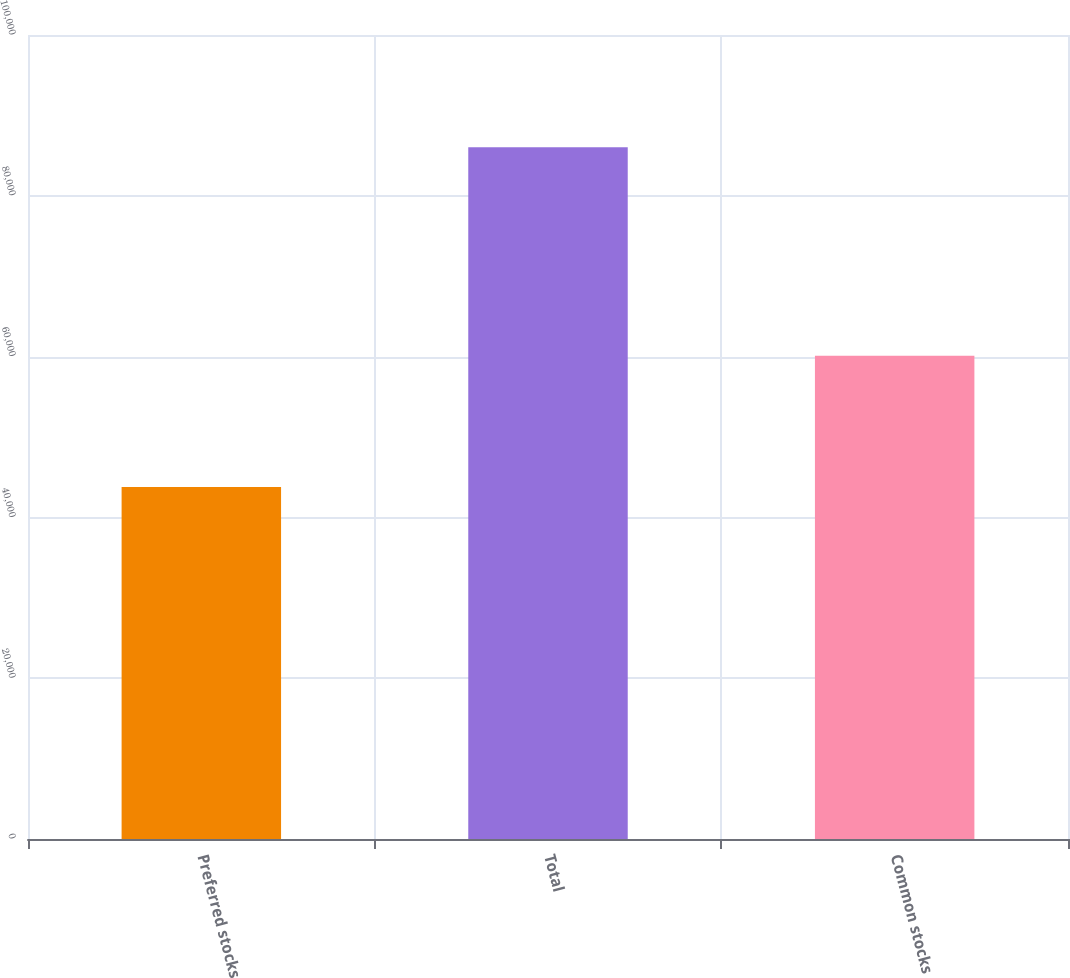Convert chart to OTSL. <chart><loc_0><loc_0><loc_500><loc_500><bar_chart><fcel>Preferred stocks<fcel>Total<fcel>Common stocks<nl><fcel>43791<fcel>86030<fcel>60102<nl></chart> 